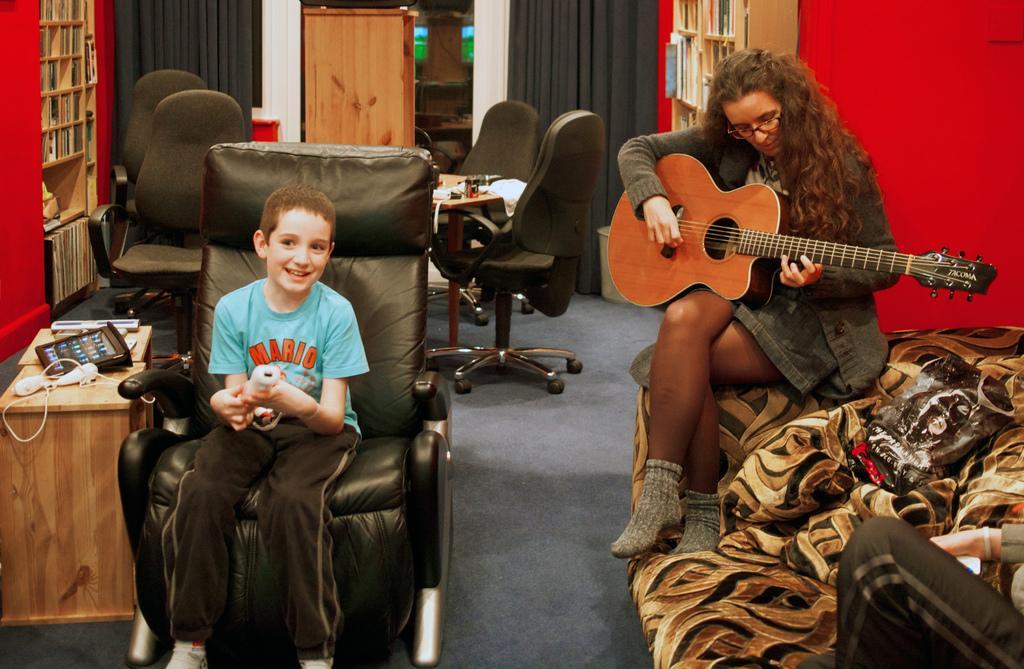Please provide a concise description of this image. Bottom left side of the image a kid is siting on a chair behind him there is a table and there is a book shelf and there are few chairs. Bottom right side of the image a woman is sitting on a couch and playing guitar. Behind her there is a wall and there is a bookshelf. 